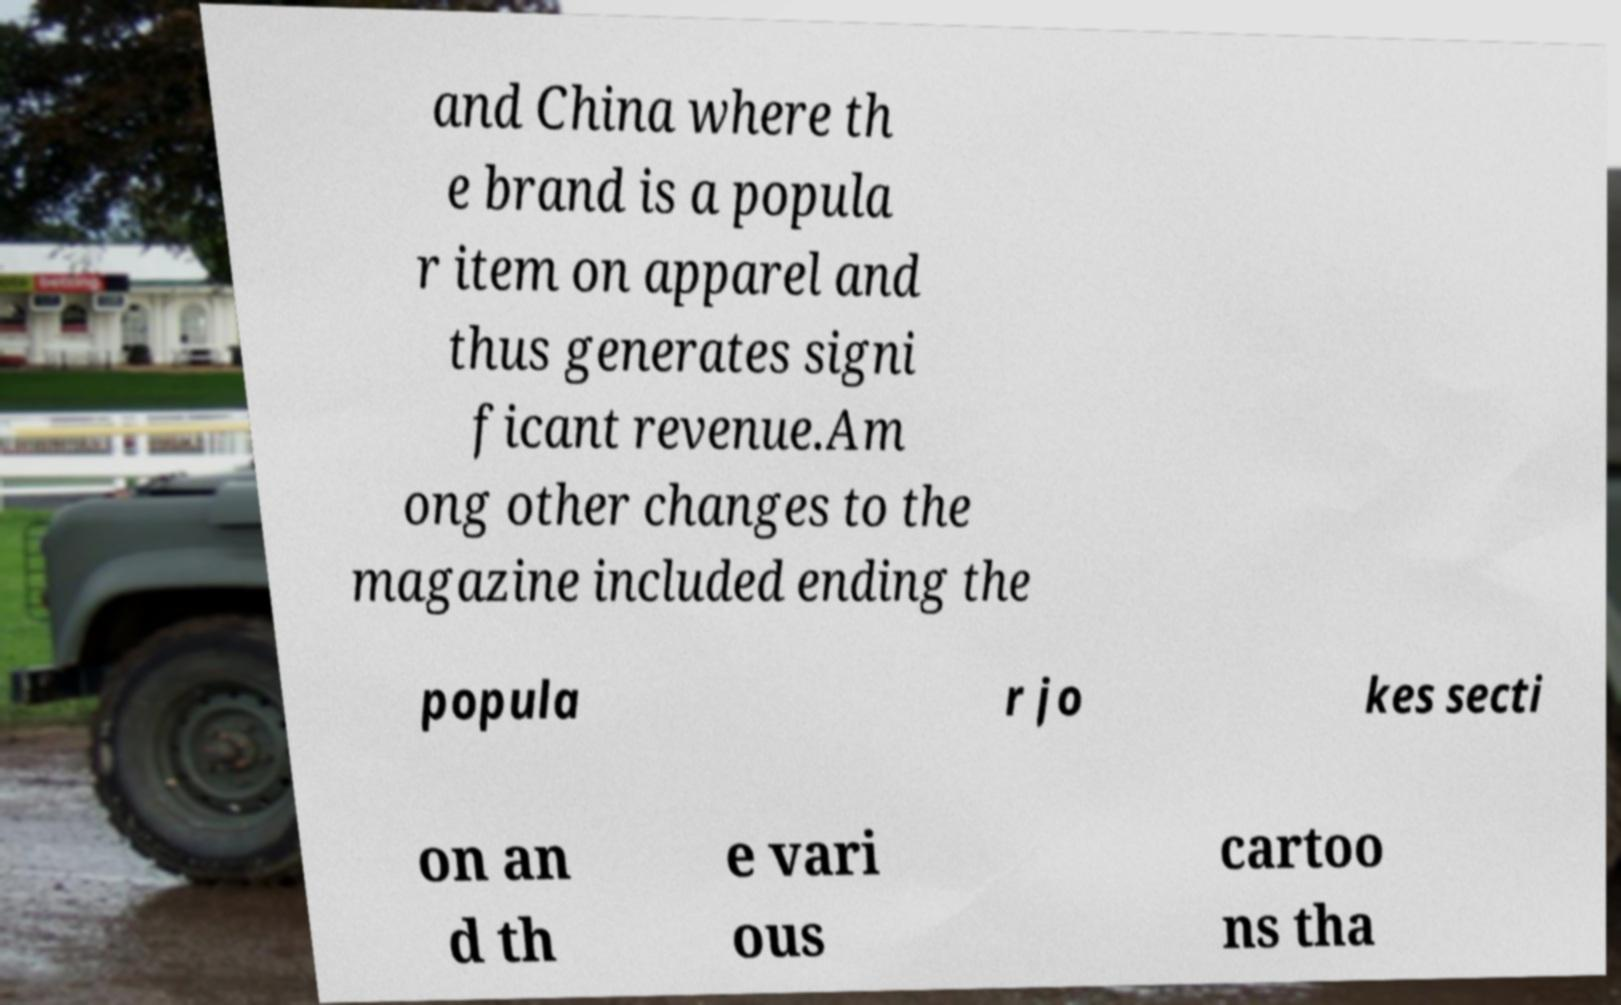I need the written content from this picture converted into text. Can you do that? and China where th e brand is a popula r item on apparel and thus generates signi ficant revenue.Am ong other changes to the magazine included ending the popula r jo kes secti on an d th e vari ous cartoo ns tha 